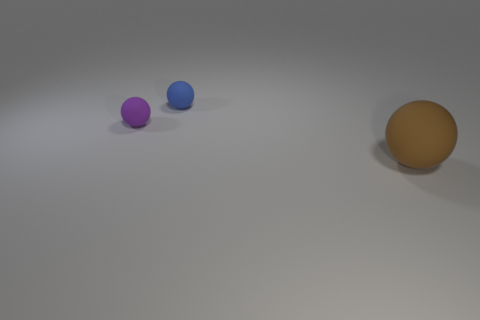Add 3 red rubber spheres. How many objects exist? 6 Add 3 tiny purple matte things. How many tiny purple matte things exist? 4 Subtract 0 red blocks. How many objects are left? 3 Subtract all brown shiny spheres. Subtract all tiny purple matte things. How many objects are left? 2 Add 1 small blue balls. How many small blue balls are left? 2 